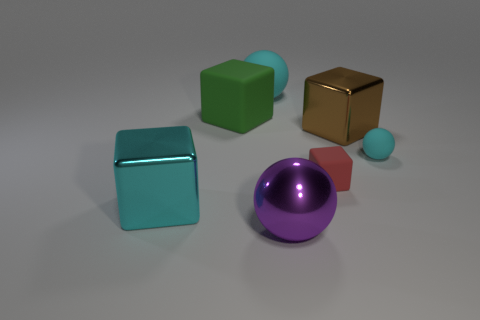Subtract all purple spheres. How many spheres are left? 2 Subtract all blue blocks. How many cyan spheres are left? 2 Subtract all red blocks. How many blocks are left? 3 Subtract 1 spheres. How many spheres are left? 2 Add 2 big cyan blocks. How many objects exist? 9 Subtract all cubes. How many objects are left? 3 Add 1 green shiny blocks. How many green shiny blocks exist? 1 Subtract 0 red spheres. How many objects are left? 7 Subtract all purple blocks. Subtract all brown spheres. How many blocks are left? 4 Subtract all small red rubber cubes. Subtract all green cubes. How many objects are left? 5 